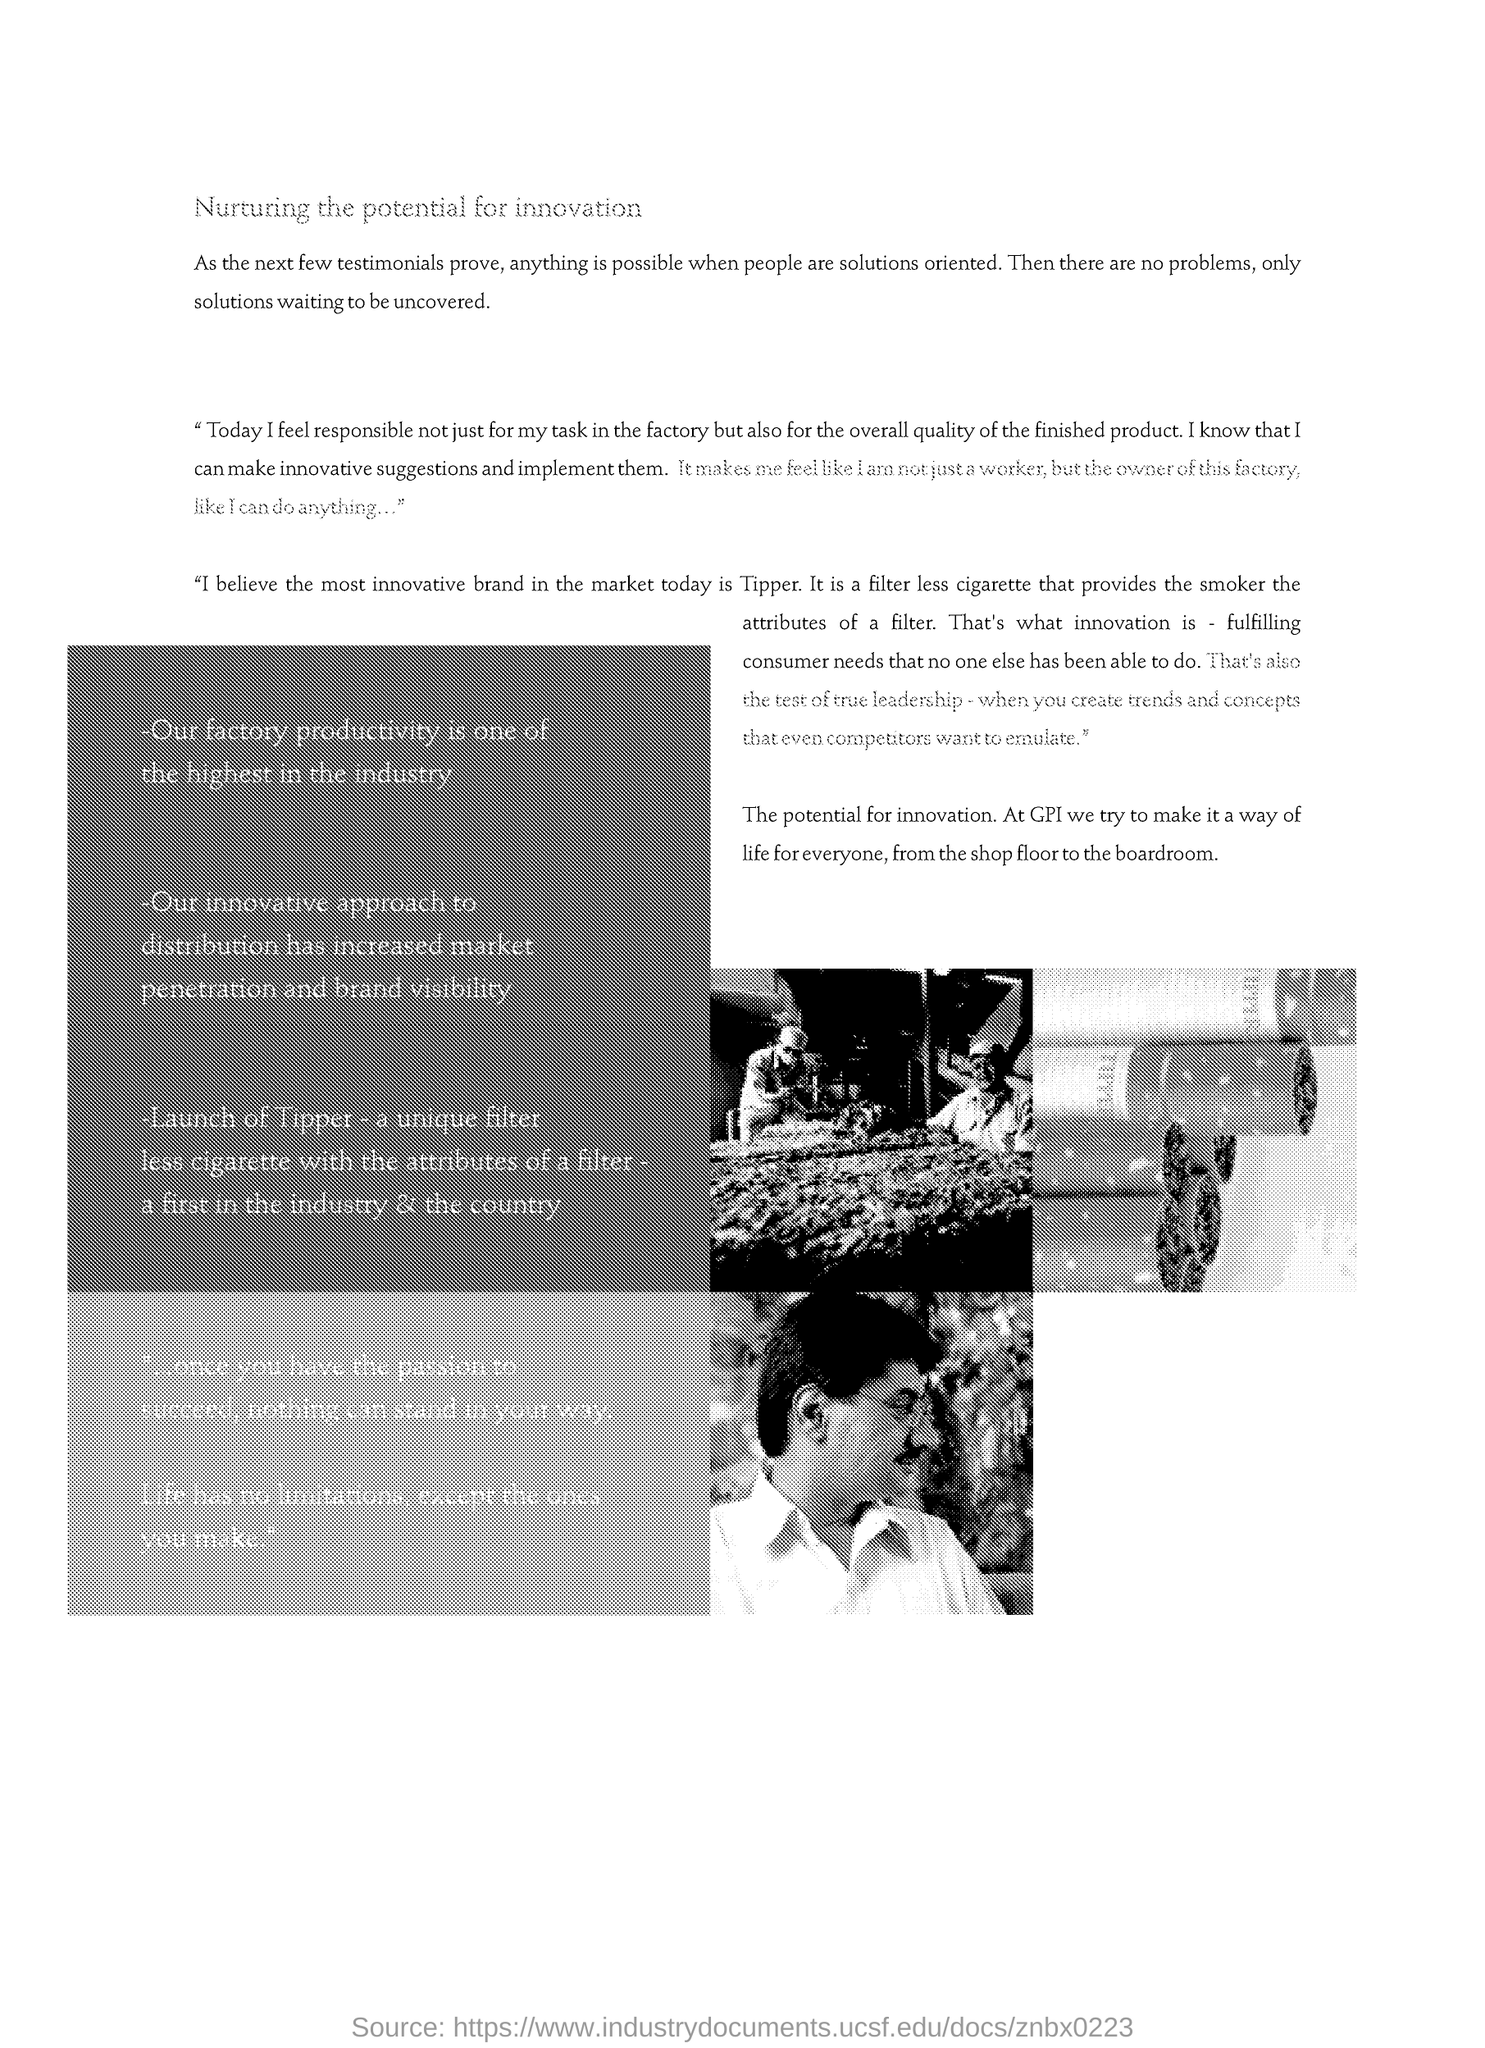What is the most innovative brand in the market today?
Your response must be concise. Tipper. Which company has made innovation as a way of life?
Your answer should be very brief. GPI. 